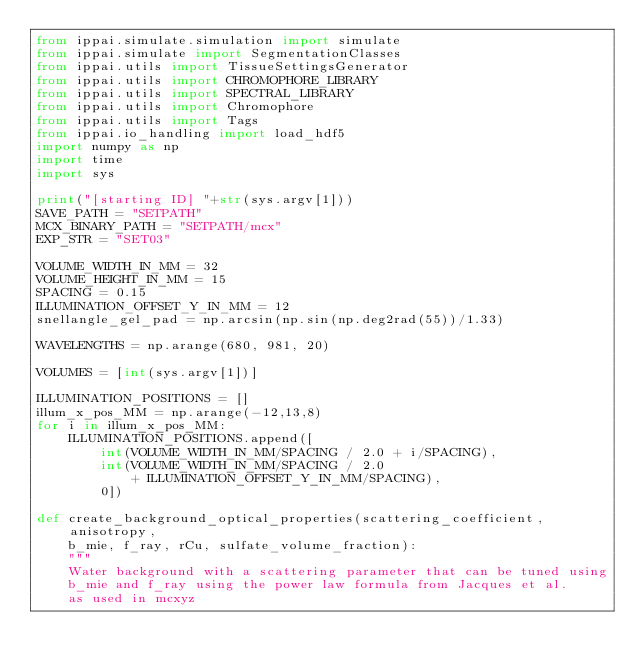<code> <loc_0><loc_0><loc_500><loc_500><_Python_>from ippai.simulate.simulation import simulate
from ippai.simulate import SegmentationClasses
from ippai.utils import TissueSettingsGenerator
from ippai.utils import CHROMOPHORE_LIBRARY
from ippai.utils import SPECTRAL_LIBRARY
from ippai.utils import Chromophore
from ippai.utils import Tags
from ippai.io_handling import load_hdf5
import numpy as np
import time
import sys

print("[starting ID] "+str(sys.argv[1]))
SAVE_PATH = "SETPATH"
MCX_BINARY_PATH = "SETPATH/mcx"
EXP_STR = "SET03"

VOLUME_WIDTH_IN_MM = 32
VOLUME_HEIGHT_IN_MM = 15
SPACING = 0.15
ILLUMINATION_OFFSET_Y_IN_MM = 12
snellangle_gel_pad = np.arcsin(np.sin(np.deg2rad(55))/1.33)

WAVELENGTHS = np.arange(680, 981, 20)

VOLUMES = [int(sys.argv[1])]

ILLUMINATION_POSITIONS = []
illum_x_pos_MM = np.arange(-12,13,8)
for i in illum_x_pos_MM:
    ILLUMINATION_POSITIONS.append([
        int(VOLUME_WIDTH_IN_MM/SPACING / 2.0 + i/SPACING),
        int(VOLUME_WIDTH_IN_MM/SPACING / 2.0 
            + ILLUMINATION_OFFSET_Y_IN_MM/SPACING), 
        0])

def create_background_optical_properties(scattering_coefficient, anisotropy, 
    b_mie, f_ray, rCu, sulfate_volume_fraction):
    """
    Water background with a scattering parameter that can be tuned using 
    b_mie and f_ray using the power law formula from Jacques et al. 
    as used in mcxyz
</code> 